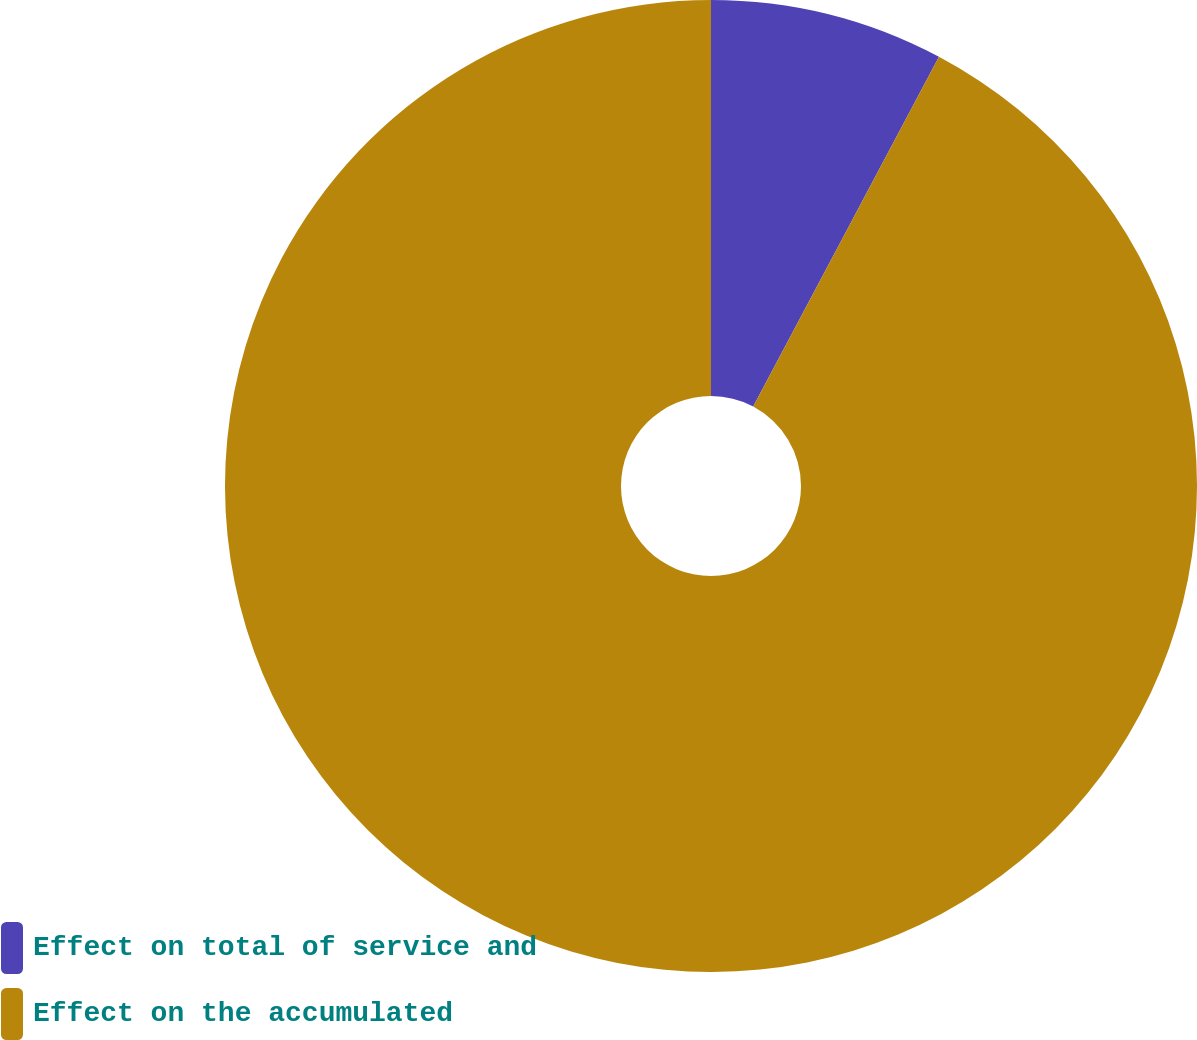<chart> <loc_0><loc_0><loc_500><loc_500><pie_chart><fcel>Effect on total of service and<fcel>Effect on the accumulated<nl><fcel>7.77%<fcel>92.23%<nl></chart> 